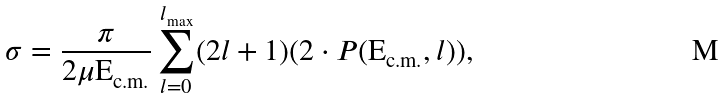<formula> <loc_0><loc_0><loc_500><loc_500>\sigma = \frac { \pi } { 2 \mu \text {E} _ { \text {c.m.} } } \sum _ { l = 0 } ^ { l _ { \max } } ( 2 l + 1 ) ( 2 \cdot P ( \text {E} _ { \text {c.m.} } , l ) ) ,</formula> 